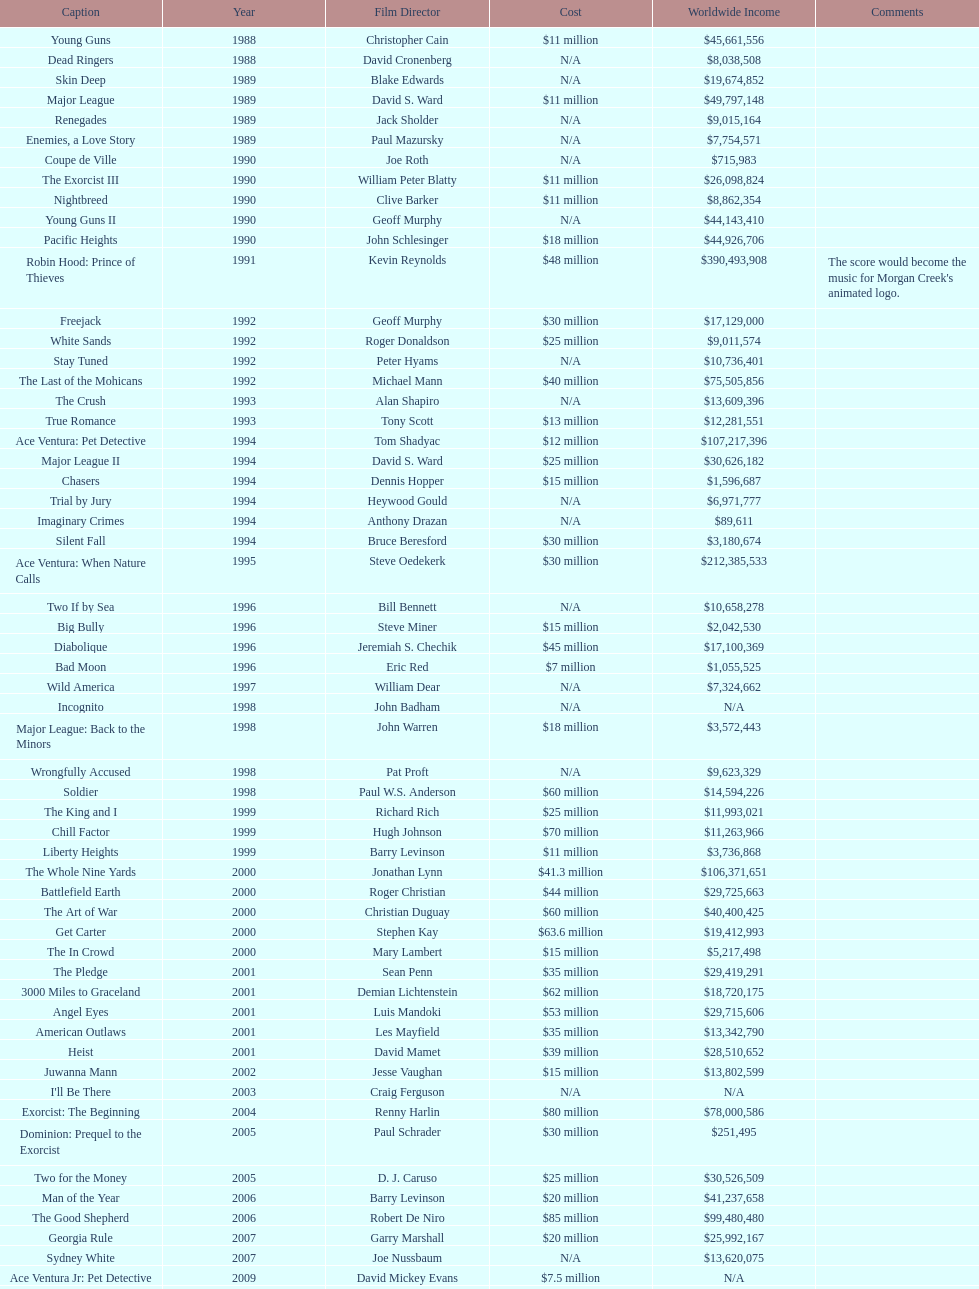What was the only movie with a 48 million dollar budget? Robin Hood: Prince of Thieves. 